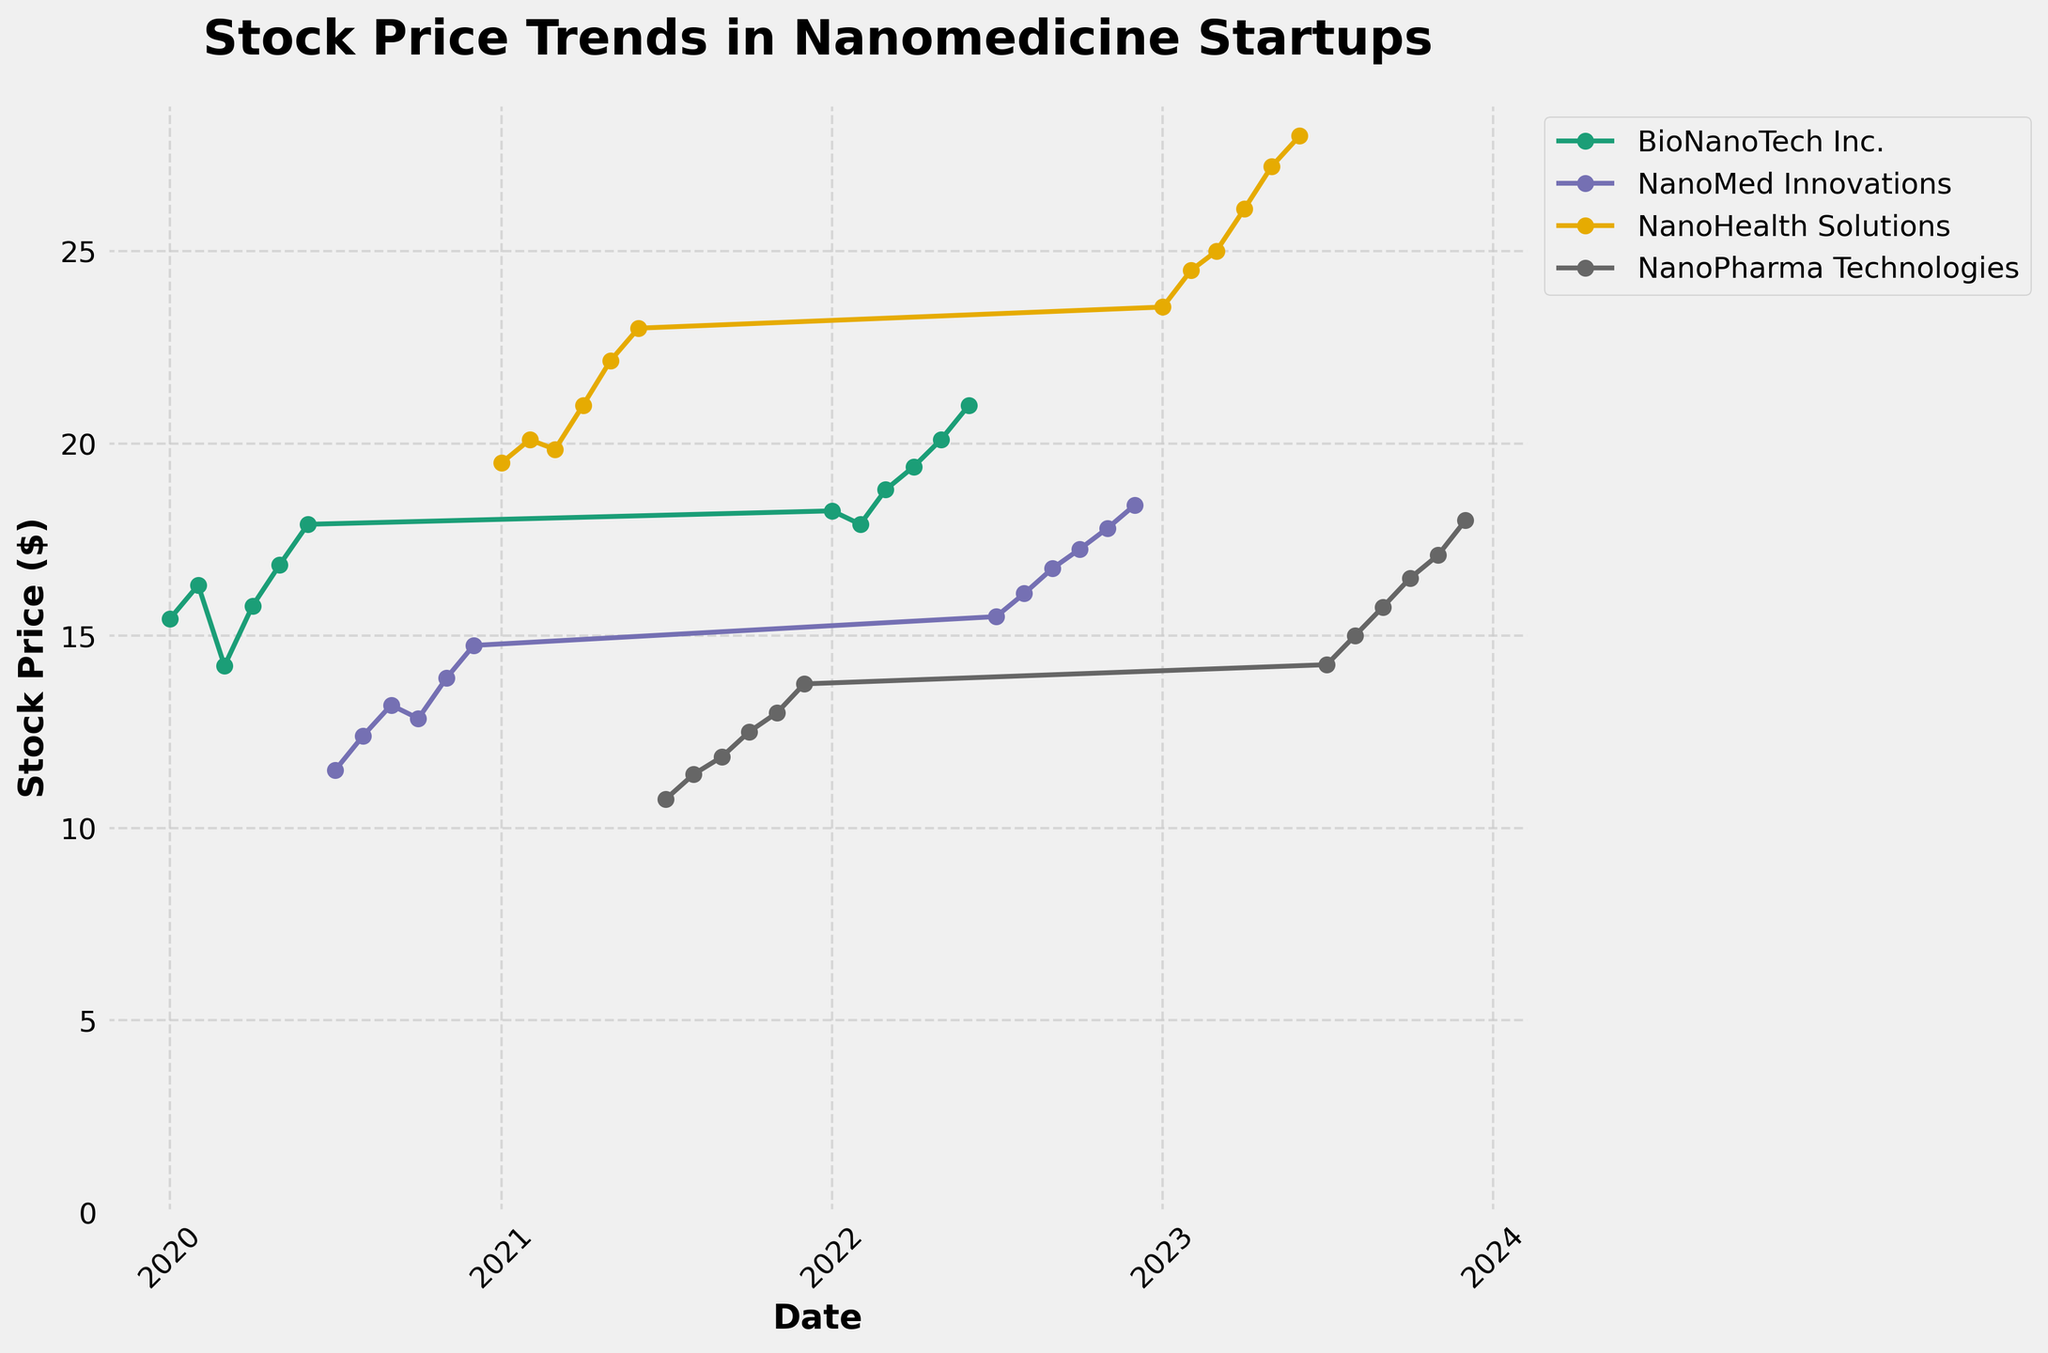what is the title of the chart? The title is located at the top of the figure, usually in a prominent position. Here, it reads 'Stock Price Trends in Nanomedicine Startups'.
Answer: Stock Price Trends in Nanomedicine Startups What are the company names displayed on the chart? There are four unique companies whose stock prices are plotted, visible in the legend at the top right of the figure. These companies are: BioNanoTech Inc., NanoMed Innovations, NanoHealth Solutions, and NanoPharma Technologies.
Answer: BioNanoTech Inc., NanoMed Innovations, NanoHealth Solutions, NanoPharma Technologies Which company had the highest stock price by December 2023? Looking at the data points for December 2023, NanoHealth Solutions reaches the highest stock price, as indicated by the topmost point on the chart for that month.
Answer: NanoHealth Solutions How did BioNanoTech Inc.'s stock price trend from January 2020 to June 2020? From January 2020 to June 2020, BioNanoTech Inc.'s stock price initially drops in March 2020 before steadily rising each subsequent month. The sequence of points shows a dip followed by an upward trend.
Answer: It fell first, then rose Compare the stock price of NanoMed Innovations in July 2020 with July 2022. In July 2020, the stock price of NanoMed Innovations is visibly lower than in July 2022. By using the vertical axis, we can see a rise from roughly 11.50 to 15.50 dollars.
Answer: It increased from 11.50 to 15.50 dollars What is the trend of NanoPharma Technologies’ stock price from July 2021 to December 2023? From July 2021, NanoPharma Technologies' stock price gradually increased, with minor fluctuations, reaching its highest point by December 2023. Each plotted point indicates continuous growth.
Answer: It gradually increased Which company had the most significant growth in stock price over the displayed period (from their respective first to last plotted date)? NanoHealth Solutions shows the most substantial growth evidenced by the steepest incline from its initial point in January 2021 to its final point in June 2023, surpassing the growth of other companies.
Answer: NanoHealth Solutions What is the average stock price of NanoMed Innovations in 2022? The stock prices of NanoMed Innovations in 2022 are January: 15.50, August: 16.10, September: 16.75, October: 17.25, November: 17.80, and December: 18.40. Summing these up gives 15.50 + 16.10 + 16.75 + 17.25 + 17.80 + 18.40 = 101.8. Dividing by 6 (number of months) provides the average: 101.8 / 6 = 16.97.
Answer: 16.97 